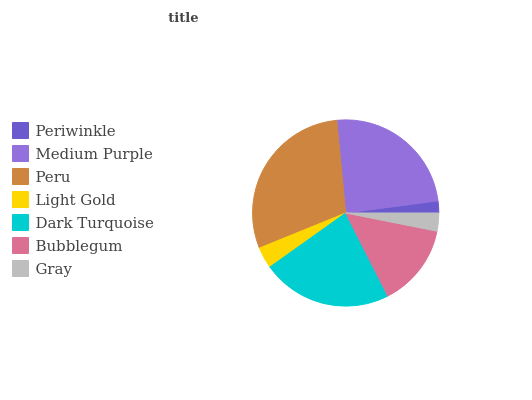Is Periwinkle the minimum?
Answer yes or no. Yes. Is Peru the maximum?
Answer yes or no. Yes. Is Medium Purple the minimum?
Answer yes or no. No. Is Medium Purple the maximum?
Answer yes or no. No. Is Medium Purple greater than Periwinkle?
Answer yes or no. Yes. Is Periwinkle less than Medium Purple?
Answer yes or no. Yes. Is Periwinkle greater than Medium Purple?
Answer yes or no. No. Is Medium Purple less than Periwinkle?
Answer yes or no. No. Is Bubblegum the high median?
Answer yes or no. Yes. Is Bubblegum the low median?
Answer yes or no. Yes. Is Medium Purple the high median?
Answer yes or no. No. Is Light Gold the low median?
Answer yes or no. No. 